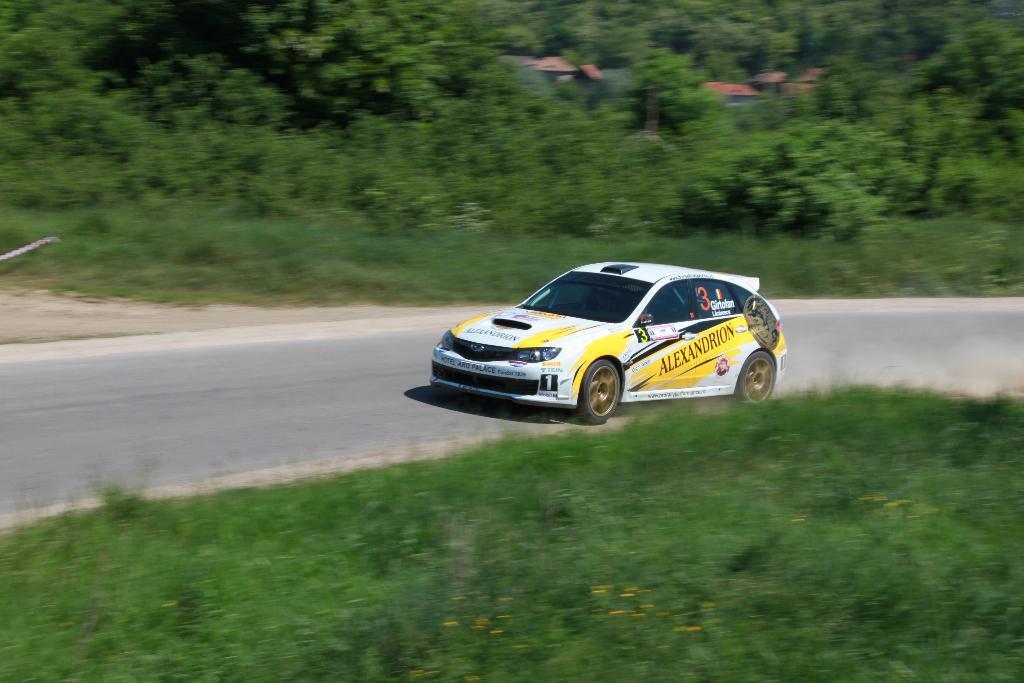Can you describe this image briefly? At the center of the image there is a car moving on the road. On the either sides of the road there are trees, plants and grass. 